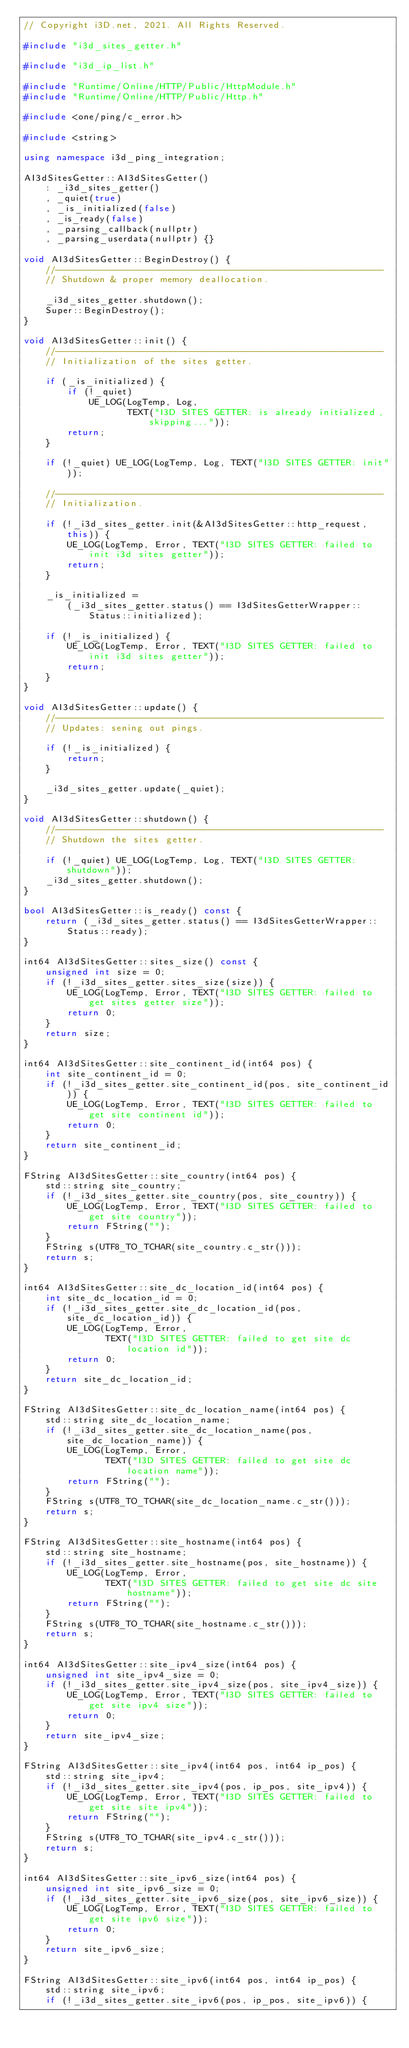<code> <loc_0><loc_0><loc_500><loc_500><_C++_>// Copyright i3D.net, 2021. All Rights Reserved.

#include "i3d_sites_getter.h"

#include "i3d_ip_list.h"

#include "Runtime/Online/HTTP/Public/HttpModule.h"
#include "Runtime/Online/HTTP/Public/Http.h"

#include <one/ping/c_error.h>

#include <string>

using namespace i3d_ping_integration;

AI3dSitesGetter::AI3dSitesGetter()
    : _i3d_sites_getter()
    , _quiet(true)
    , _is_initialized(false)
    , _is_ready(false)
    , _parsing_callback(nullptr)
    , _parsing_userdata(nullptr) {}

void AI3dSitesGetter::BeginDestroy() {
    //------------------------------------------------------------
    // Shutdown & proper memory deallocation.

    _i3d_sites_getter.shutdown();
    Super::BeginDestroy();
}

void AI3dSitesGetter::init() {
    //------------------------------------------------------------
    // Initialization of the sites getter.

    if (_is_initialized) {
        if (!_quiet)
            UE_LOG(LogTemp, Log,
                   TEXT("I3D SITES GETTER: is already initialized, skipping..."));
        return;
    }

    if (!_quiet) UE_LOG(LogTemp, Log, TEXT("I3D SITES GETTER: init"));

    //------------------------------------------------------------
    // Initialization.

    if (!_i3d_sites_getter.init(&AI3dSitesGetter::http_request, this)) {
        UE_LOG(LogTemp, Error, TEXT("I3D SITES GETTER: failed to init i3d sites getter"));
        return;
    }

    _is_initialized =
        (_i3d_sites_getter.status() == I3dSitesGetterWrapper::Status::initialized);

    if (!_is_initialized) {
        UE_LOG(LogTemp, Error, TEXT("I3D SITES GETTER: failed to init i3d sites getter"));
        return;
    }
}

void AI3dSitesGetter::update() {
    //------------------------------------------------------------
    // Updates: sening out pings.

    if (!_is_initialized) {
        return;
    }

    _i3d_sites_getter.update(_quiet);
}

void AI3dSitesGetter::shutdown() {
    //------------------------------------------------------------
    // Shutdown the sites getter.

    if (!_quiet) UE_LOG(LogTemp, Log, TEXT("I3D SITES GETTER: shutdown"));
    _i3d_sites_getter.shutdown();
}

bool AI3dSitesGetter::is_ready() const {
    return (_i3d_sites_getter.status() == I3dSitesGetterWrapper::Status::ready);
}

int64 AI3dSitesGetter::sites_size() const {
    unsigned int size = 0;
    if (!_i3d_sites_getter.sites_size(size)) {
        UE_LOG(LogTemp, Error, TEXT("I3D SITES GETTER: failed to get sites getter size"));
        return 0;
    }
    return size;
}

int64 AI3dSitesGetter::site_continent_id(int64 pos) {
    int site_continent_id = 0;
    if (!_i3d_sites_getter.site_continent_id(pos, site_continent_id)) {
        UE_LOG(LogTemp, Error, TEXT("I3D SITES GETTER: failed to get site continent id"));
        return 0;
    }
    return site_continent_id;
}

FString AI3dSitesGetter::site_country(int64 pos) {
    std::string site_country;
    if (!_i3d_sites_getter.site_country(pos, site_country)) {
        UE_LOG(LogTemp, Error, TEXT("I3D SITES GETTER: failed to get site country"));
        return FString("");
    }
    FString s(UTF8_TO_TCHAR(site_country.c_str()));
    return s;
}

int64 AI3dSitesGetter::site_dc_location_id(int64 pos) {
    int site_dc_location_id = 0;
    if (!_i3d_sites_getter.site_dc_location_id(pos, site_dc_location_id)) {
        UE_LOG(LogTemp, Error,
               TEXT("I3D SITES GETTER: failed to get site dc location id"));
        return 0;
    }
    return site_dc_location_id;
}

FString AI3dSitesGetter::site_dc_location_name(int64 pos) {
    std::string site_dc_location_name;
    if (!_i3d_sites_getter.site_dc_location_name(pos, site_dc_location_name)) {
        UE_LOG(LogTemp, Error,
               TEXT("I3D SITES GETTER: failed to get site dc location name"));
        return FString("");
    }
    FString s(UTF8_TO_TCHAR(site_dc_location_name.c_str()));
    return s;
}

FString AI3dSitesGetter::site_hostname(int64 pos) {
    std::string site_hostname;
    if (!_i3d_sites_getter.site_hostname(pos, site_hostname)) {
        UE_LOG(LogTemp, Error,
               TEXT("I3D SITES GETTER: failed to get site dc site hostname"));
        return FString("");
    }
    FString s(UTF8_TO_TCHAR(site_hostname.c_str()));
    return s;
}

int64 AI3dSitesGetter::site_ipv4_size(int64 pos) {
    unsigned int site_ipv4_size = 0;
    if (!_i3d_sites_getter.site_ipv4_size(pos, site_ipv4_size)) {
        UE_LOG(LogTemp, Error, TEXT("I3D SITES GETTER: failed to get site ipv4 size"));
        return 0;
    }
    return site_ipv4_size;
}

FString AI3dSitesGetter::site_ipv4(int64 pos, int64 ip_pos) {
    std::string site_ipv4;
    if (!_i3d_sites_getter.site_ipv4(pos, ip_pos, site_ipv4)) {
        UE_LOG(LogTemp, Error, TEXT("I3D SITES GETTER: failed to get site site ipv4"));
        return FString("");
    }
    FString s(UTF8_TO_TCHAR(site_ipv4.c_str()));
    return s;
}

int64 AI3dSitesGetter::site_ipv6_size(int64 pos) {
    unsigned int site_ipv6_size = 0;
    if (!_i3d_sites_getter.site_ipv6_size(pos, site_ipv6_size)) {
        UE_LOG(LogTemp, Error, TEXT("I3D SITES GETTER: failed to get site ipv6 size"));
        return 0;
    }
    return site_ipv6_size;
}

FString AI3dSitesGetter::site_ipv6(int64 pos, int64 ip_pos) {
    std::string site_ipv6;
    if (!_i3d_sites_getter.site_ipv6(pos, ip_pos, site_ipv6)) {</code> 